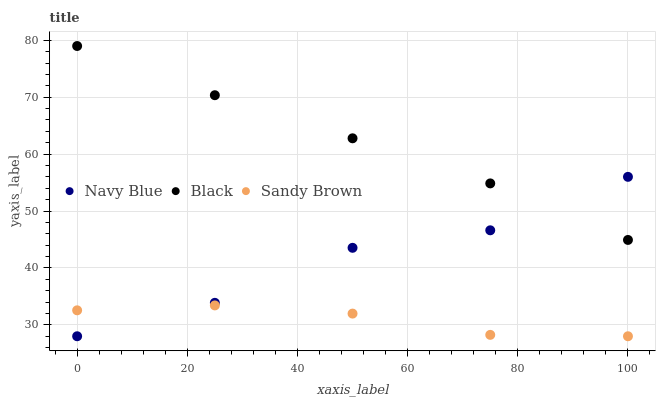Does Sandy Brown have the minimum area under the curve?
Answer yes or no. Yes. Does Black have the maximum area under the curve?
Answer yes or no. Yes. Does Black have the minimum area under the curve?
Answer yes or no. No. Does Sandy Brown have the maximum area under the curve?
Answer yes or no. No. Is Black the smoothest?
Answer yes or no. Yes. Is Navy Blue the roughest?
Answer yes or no. Yes. Is Sandy Brown the smoothest?
Answer yes or no. No. Is Sandy Brown the roughest?
Answer yes or no. No. Does Navy Blue have the lowest value?
Answer yes or no. Yes. Does Black have the lowest value?
Answer yes or no. No. Does Black have the highest value?
Answer yes or no. Yes. Does Sandy Brown have the highest value?
Answer yes or no. No. Is Sandy Brown less than Black?
Answer yes or no. Yes. Is Black greater than Sandy Brown?
Answer yes or no. Yes. Does Navy Blue intersect Black?
Answer yes or no. Yes. Is Navy Blue less than Black?
Answer yes or no. No. Is Navy Blue greater than Black?
Answer yes or no. No. Does Sandy Brown intersect Black?
Answer yes or no. No. 